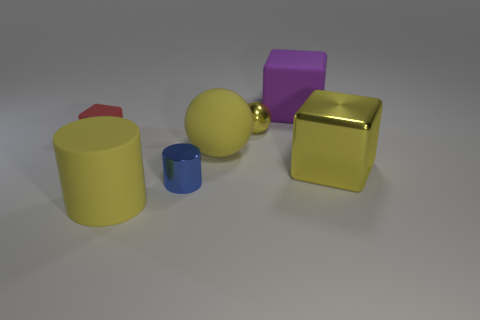What is the material of the cube that is on the left side of the metal cylinder?
Provide a succinct answer. Rubber. What number of yellow objects have the same shape as the blue object?
Offer a terse response. 1. What shape is the small blue object that is the same material as the big yellow cube?
Give a very brief answer. Cylinder. There is a yellow matte thing that is behind the metal thing on the right side of the small shiny object behind the large yellow shiny object; what shape is it?
Keep it short and to the point. Sphere. Is the number of small cylinders greater than the number of big yellow matte things?
Provide a succinct answer. No. What is the material of the large thing that is the same shape as the tiny blue object?
Provide a succinct answer. Rubber. Are the yellow cube and the big yellow cylinder made of the same material?
Offer a very short reply. No. Is the number of objects on the left side of the yellow matte sphere greater than the number of yellow blocks?
Give a very brief answer. Yes. There is a tiny object that is behind the block that is left of the cylinder that is behind the large cylinder; what is it made of?
Your answer should be compact. Metal. How many objects are tiny things or blocks that are in front of the purple thing?
Keep it short and to the point. 4. 